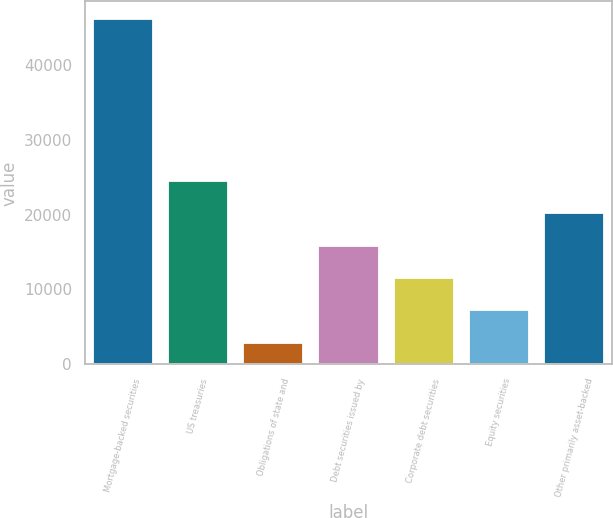Convert chart to OTSL. <chart><loc_0><loc_0><loc_500><loc_500><bar_chart><fcel>Mortgage-backed securities<fcel>US treasuries<fcel>Obligations of state and<fcel>Debt securities issued by<fcel>Corporate debt securities<fcel>Equity securities<fcel>Other primarily asset-backed<nl><fcel>46141<fcel>24503.5<fcel>2866<fcel>15848.5<fcel>11521<fcel>7193.5<fcel>20176<nl></chart> 